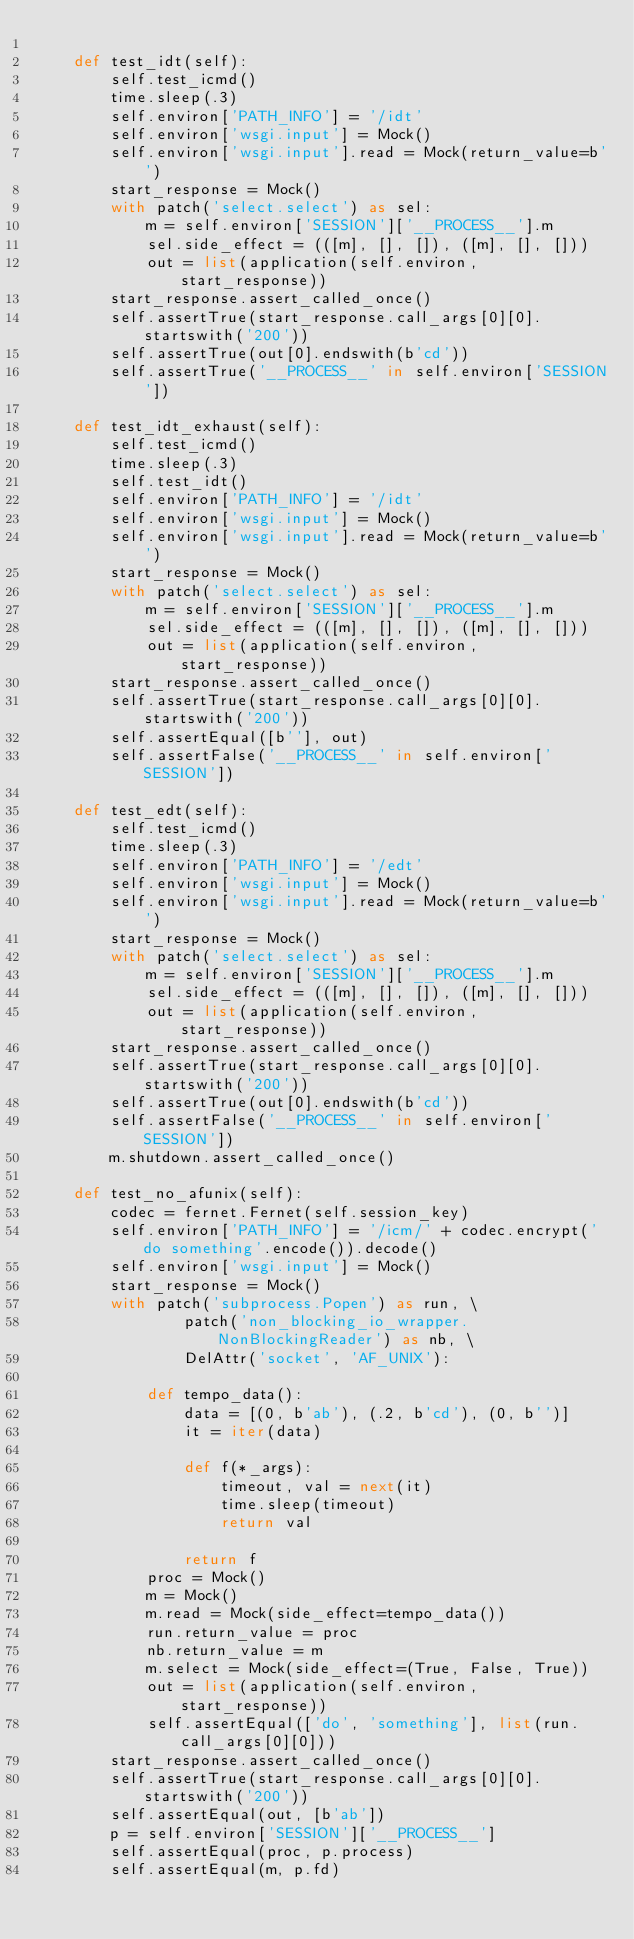<code> <loc_0><loc_0><loc_500><loc_500><_Python_>
    def test_idt(self):
        self.test_icmd()
        time.sleep(.3)
        self.environ['PATH_INFO'] = '/idt'
        self.environ['wsgi.input'] = Mock()
        self.environ['wsgi.input'].read = Mock(return_value=b'')
        start_response = Mock()
        with patch('select.select') as sel:
            m = self.environ['SESSION']['__PROCESS__'].m
            sel.side_effect = (([m], [], []), ([m], [], []))
            out = list(application(self.environ, start_response))
        start_response.assert_called_once()
        self.assertTrue(start_response.call_args[0][0].startswith('200'))
        self.assertTrue(out[0].endswith(b'cd'))
        self.assertTrue('__PROCESS__' in self.environ['SESSION'])

    def test_idt_exhaust(self):
        self.test_icmd()
        time.sleep(.3)
        self.test_idt()
        self.environ['PATH_INFO'] = '/idt'
        self.environ['wsgi.input'] = Mock()
        self.environ['wsgi.input'].read = Mock(return_value=b'')
        start_response = Mock()
        with patch('select.select') as sel:
            m = self.environ['SESSION']['__PROCESS__'].m
            sel.side_effect = (([m], [], []), ([m], [], []))
            out = list(application(self.environ, start_response))
        start_response.assert_called_once()
        self.assertTrue(start_response.call_args[0][0].startswith('200'))
        self.assertEqual([b''], out)
        self.assertFalse('__PROCESS__' in self.environ['SESSION'])

    def test_edt(self):
        self.test_icmd()
        time.sleep(.3)
        self.environ['PATH_INFO'] = '/edt'
        self.environ['wsgi.input'] = Mock()
        self.environ['wsgi.input'].read = Mock(return_value=b'')
        start_response = Mock()
        with patch('select.select') as sel:
            m = self.environ['SESSION']['__PROCESS__'].m
            sel.side_effect = (([m], [], []), ([m], [], []))
            out = list(application(self.environ, start_response))
        start_response.assert_called_once()
        self.assertTrue(start_response.call_args[0][0].startswith('200'))
        self.assertTrue(out[0].endswith(b'cd'))
        self.assertFalse('__PROCESS__' in self.environ['SESSION'])
        m.shutdown.assert_called_once()

    def test_no_afunix(self):
        codec = fernet.Fernet(self.session_key)
        self.environ['PATH_INFO'] = '/icm/' + codec.encrypt('do something'.encode()).decode()
        self.environ['wsgi.input'] = Mock()
        start_response = Mock()
        with patch('subprocess.Popen') as run, \
                patch('non_blocking_io_wrapper.NonBlockingReader') as nb, \
                DelAttr('socket', 'AF_UNIX'):

            def tempo_data():
                data = [(0, b'ab'), (.2, b'cd'), (0, b'')]
                it = iter(data)

                def f(*_args):
                    timeout, val = next(it)
                    time.sleep(timeout)
                    return val

                return f
            proc = Mock()
            m = Mock()
            m.read = Mock(side_effect=tempo_data())
            run.return_value = proc
            nb.return_value = m
            m.select = Mock(side_effect=(True, False, True))
            out = list(application(self.environ, start_response))
            self.assertEqual(['do', 'something'], list(run.call_args[0][0]))
        start_response.assert_called_once()
        self.assertTrue(start_response.call_args[0][0].startswith('200'))
        self.assertEqual(out, [b'ab'])
        p = self.environ['SESSION']['__PROCESS__']
        self.assertEqual(proc, p.process)
        self.assertEqual(m, p.fd)
</code> 